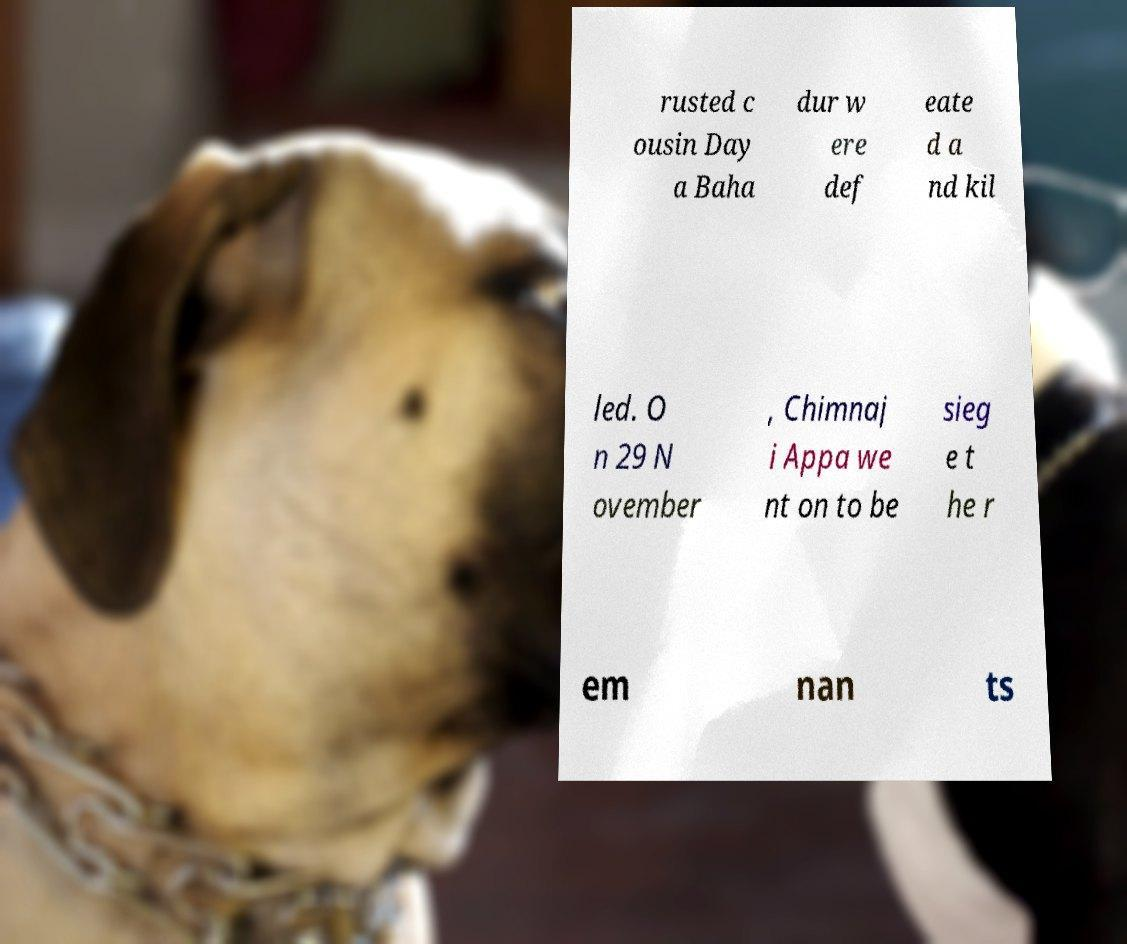For documentation purposes, I need the text within this image transcribed. Could you provide that? rusted c ousin Day a Baha dur w ere def eate d a nd kil led. O n 29 N ovember , Chimnaj i Appa we nt on to be sieg e t he r em nan ts 